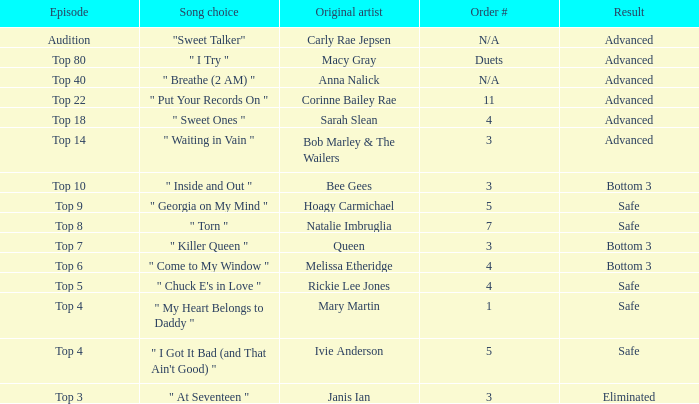What is the overall count of songs originally sung by anna nalick? 1.0. 